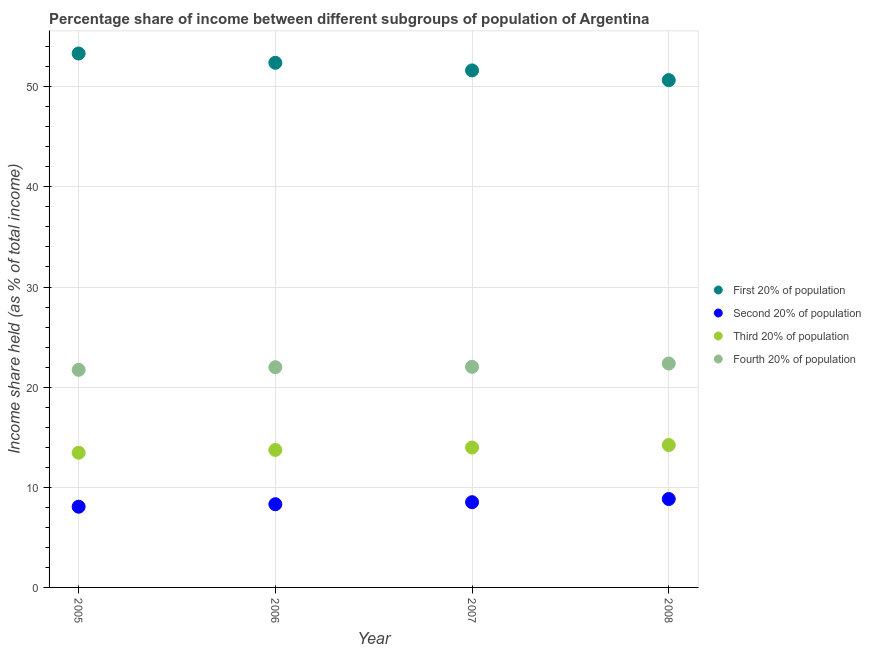How many different coloured dotlines are there?
Provide a succinct answer. 4. What is the share of the income held by third 20% of the population in 2005?
Offer a very short reply. 13.45. Across all years, what is the maximum share of the income held by second 20% of the population?
Offer a very short reply. 8.83. Across all years, what is the minimum share of the income held by third 20% of the population?
Offer a very short reply. 13.45. What is the total share of the income held by second 20% of the population in the graph?
Give a very brief answer. 33.71. What is the difference between the share of the income held by first 20% of the population in 2005 and that in 2008?
Make the answer very short. 2.66. What is the difference between the share of the income held by first 20% of the population in 2006 and the share of the income held by second 20% of the population in 2008?
Offer a very short reply. 43.56. What is the average share of the income held by fourth 20% of the population per year?
Offer a terse response. 22.03. In the year 2007, what is the difference between the share of the income held by third 20% of the population and share of the income held by first 20% of the population?
Make the answer very short. -37.66. In how many years, is the share of the income held by second 20% of the population greater than 6 %?
Offer a very short reply. 4. What is the ratio of the share of the income held by second 20% of the population in 2006 to that in 2007?
Keep it short and to the point. 0.98. What is the difference between the highest and the second highest share of the income held by first 20% of the population?
Provide a succinct answer. 0.93. What is the difference between the highest and the lowest share of the income held by third 20% of the population?
Provide a succinct answer. 0.77. Is the sum of the share of the income held by second 20% of the population in 2005 and 2008 greater than the maximum share of the income held by third 20% of the population across all years?
Keep it short and to the point. Yes. Is it the case that in every year, the sum of the share of the income held by first 20% of the population and share of the income held by fourth 20% of the population is greater than the sum of share of the income held by second 20% of the population and share of the income held by third 20% of the population?
Provide a short and direct response. Yes. Does the share of the income held by second 20% of the population monotonically increase over the years?
Offer a very short reply. Yes. What is the difference between two consecutive major ticks on the Y-axis?
Offer a very short reply. 10. Does the graph contain grids?
Provide a succinct answer. Yes. Where does the legend appear in the graph?
Give a very brief answer. Center right. How many legend labels are there?
Offer a terse response. 4. How are the legend labels stacked?
Provide a succinct answer. Vertical. What is the title of the graph?
Your answer should be compact. Percentage share of income between different subgroups of population of Argentina. What is the label or title of the X-axis?
Offer a terse response. Year. What is the label or title of the Y-axis?
Ensure brevity in your answer.  Income share held (as % of total income). What is the Income share held (as % of total income) of First 20% of population in 2005?
Your answer should be very brief. 53.32. What is the Income share held (as % of total income) in Second 20% of population in 2005?
Give a very brief answer. 8.06. What is the Income share held (as % of total income) in Third 20% of population in 2005?
Offer a terse response. 13.45. What is the Income share held (as % of total income) of Fourth 20% of population in 2005?
Your response must be concise. 21.73. What is the Income share held (as % of total income) in First 20% of population in 2006?
Make the answer very short. 52.39. What is the Income share held (as % of total income) in Second 20% of population in 2006?
Your answer should be very brief. 8.31. What is the Income share held (as % of total income) of Third 20% of population in 2006?
Ensure brevity in your answer.  13.73. What is the Income share held (as % of total income) in Fourth 20% of population in 2006?
Provide a succinct answer. 21.99. What is the Income share held (as % of total income) in First 20% of population in 2007?
Your response must be concise. 51.63. What is the Income share held (as % of total income) of Second 20% of population in 2007?
Your answer should be compact. 8.51. What is the Income share held (as % of total income) in Third 20% of population in 2007?
Your answer should be very brief. 13.97. What is the Income share held (as % of total income) in Fourth 20% of population in 2007?
Give a very brief answer. 22.03. What is the Income share held (as % of total income) of First 20% of population in 2008?
Offer a very short reply. 50.66. What is the Income share held (as % of total income) of Second 20% of population in 2008?
Your response must be concise. 8.83. What is the Income share held (as % of total income) in Third 20% of population in 2008?
Provide a succinct answer. 14.22. What is the Income share held (as % of total income) in Fourth 20% of population in 2008?
Provide a short and direct response. 22.36. Across all years, what is the maximum Income share held (as % of total income) of First 20% of population?
Make the answer very short. 53.32. Across all years, what is the maximum Income share held (as % of total income) of Second 20% of population?
Give a very brief answer. 8.83. Across all years, what is the maximum Income share held (as % of total income) in Third 20% of population?
Ensure brevity in your answer.  14.22. Across all years, what is the maximum Income share held (as % of total income) of Fourth 20% of population?
Give a very brief answer. 22.36. Across all years, what is the minimum Income share held (as % of total income) in First 20% of population?
Make the answer very short. 50.66. Across all years, what is the minimum Income share held (as % of total income) of Second 20% of population?
Give a very brief answer. 8.06. Across all years, what is the minimum Income share held (as % of total income) of Third 20% of population?
Your answer should be compact. 13.45. Across all years, what is the minimum Income share held (as % of total income) of Fourth 20% of population?
Your answer should be very brief. 21.73. What is the total Income share held (as % of total income) of First 20% of population in the graph?
Your answer should be very brief. 208. What is the total Income share held (as % of total income) in Second 20% of population in the graph?
Make the answer very short. 33.71. What is the total Income share held (as % of total income) of Third 20% of population in the graph?
Ensure brevity in your answer.  55.37. What is the total Income share held (as % of total income) in Fourth 20% of population in the graph?
Your response must be concise. 88.11. What is the difference between the Income share held (as % of total income) of First 20% of population in 2005 and that in 2006?
Provide a succinct answer. 0.93. What is the difference between the Income share held (as % of total income) in Third 20% of population in 2005 and that in 2006?
Provide a succinct answer. -0.28. What is the difference between the Income share held (as % of total income) in Fourth 20% of population in 2005 and that in 2006?
Your answer should be very brief. -0.26. What is the difference between the Income share held (as % of total income) of First 20% of population in 2005 and that in 2007?
Keep it short and to the point. 1.69. What is the difference between the Income share held (as % of total income) of Second 20% of population in 2005 and that in 2007?
Provide a succinct answer. -0.45. What is the difference between the Income share held (as % of total income) in Third 20% of population in 2005 and that in 2007?
Ensure brevity in your answer.  -0.52. What is the difference between the Income share held (as % of total income) of First 20% of population in 2005 and that in 2008?
Your answer should be compact. 2.66. What is the difference between the Income share held (as % of total income) in Second 20% of population in 2005 and that in 2008?
Offer a terse response. -0.77. What is the difference between the Income share held (as % of total income) of Third 20% of population in 2005 and that in 2008?
Your answer should be very brief. -0.77. What is the difference between the Income share held (as % of total income) in Fourth 20% of population in 2005 and that in 2008?
Your response must be concise. -0.63. What is the difference between the Income share held (as % of total income) in First 20% of population in 2006 and that in 2007?
Your response must be concise. 0.76. What is the difference between the Income share held (as % of total income) of Third 20% of population in 2006 and that in 2007?
Your response must be concise. -0.24. What is the difference between the Income share held (as % of total income) of Fourth 20% of population in 2006 and that in 2007?
Keep it short and to the point. -0.04. What is the difference between the Income share held (as % of total income) of First 20% of population in 2006 and that in 2008?
Keep it short and to the point. 1.73. What is the difference between the Income share held (as % of total income) in Second 20% of population in 2006 and that in 2008?
Provide a succinct answer. -0.52. What is the difference between the Income share held (as % of total income) of Third 20% of population in 2006 and that in 2008?
Provide a succinct answer. -0.49. What is the difference between the Income share held (as % of total income) in Fourth 20% of population in 2006 and that in 2008?
Your response must be concise. -0.37. What is the difference between the Income share held (as % of total income) of Second 20% of population in 2007 and that in 2008?
Your answer should be compact. -0.32. What is the difference between the Income share held (as % of total income) in Fourth 20% of population in 2007 and that in 2008?
Your answer should be very brief. -0.33. What is the difference between the Income share held (as % of total income) of First 20% of population in 2005 and the Income share held (as % of total income) of Second 20% of population in 2006?
Offer a terse response. 45.01. What is the difference between the Income share held (as % of total income) in First 20% of population in 2005 and the Income share held (as % of total income) in Third 20% of population in 2006?
Provide a succinct answer. 39.59. What is the difference between the Income share held (as % of total income) in First 20% of population in 2005 and the Income share held (as % of total income) in Fourth 20% of population in 2006?
Provide a short and direct response. 31.33. What is the difference between the Income share held (as % of total income) in Second 20% of population in 2005 and the Income share held (as % of total income) in Third 20% of population in 2006?
Your answer should be compact. -5.67. What is the difference between the Income share held (as % of total income) in Second 20% of population in 2005 and the Income share held (as % of total income) in Fourth 20% of population in 2006?
Offer a very short reply. -13.93. What is the difference between the Income share held (as % of total income) of Third 20% of population in 2005 and the Income share held (as % of total income) of Fourth 20% of population in 2006?
Give a very brief answer. -8.54. What is the difference between the Income share held (as % of total income) of First 20% of population in 2005 and the Income share held (as % of total income) of Second 20% of population in 2007?
Ensure brevity in your answer.  44.81. What is the difference between the Income share held (as % of total income) of First 20% of population in 2005 and the Income share held (as % of total income) of Third 20% of population in 2007?
Your answer should be compact. 39.35. What is the difference between the Income share held (as % of total income) in First 20% of population in 2005 and the Income share held (as % of total income) in Fourth 20% of population in 2007?
Make the answer very short. 31.29. What is the difference between the Income share held (as % of total income) in Second 20% of population in 2005 and the Income share held (as % of total income) in Third 20% of population in 2007?
Make the answer very short. -5.91. What is the difference between the Income share held (as % of total income) of Second 20% of population in 2005 and the Income share held (as % of total income) of Fourth 20% of population in 2007?
Keep it short and to the point. -13.97. What is the difference between the Income share held (as % of total income) in Third 20% of population in 2005 and the Income share held (as % of total income) in Fourth 20% of population in 2007?
Keep it short and to the point. -8.58. What is the difference between the Income share held (as % of total income) in First 20% of population in 2005 and the Income share held (as % of total income) in Second 20% of population in 2008?
Your answer should be compact. 44.49. What is the difference between the Income share held (as % of total income) of First 20% of population in 2005 and the Income share held (as % of total income) of Third 20% of population in 2008?
Give a very brief answer. 39.1. What is the difference between the Income share held (as % of total income) in First 20% of population in 2005 and the Income share held (as % of total income) in Fourth 20% of population in 2008?
Give a very brief answer. 30.96. What is the difference between the Income share held (as % of total income) in Second 20% of population in 2005 and the Income share held (as % of total income) in Third 20% of population in 2008?
Give a very brief answer. -6.16. What is the difference between the Income share held (as % of total income) in Second 20% of population in 2005 and the Income share held (as % of total income) in Fourth 20% of population in 2008?
Your response must be concise. -14.3. What is the difference between the Income share held (as % of total income) in Third 20% of population in 2005 and the Income share held (as % of total income) in Fourth 20% of population in 2008?
Your answer should be very brief. -8.91. What is the difference between the Income share held (as % of total income) of First 20% of population in 2006 and the Income share held (as % of total income) of Second 20% of population in 2007?
Your answer should be very brief. 43.88. What is the difference between the Income share held (as % of total income) of First 20% of population in 2006 and the Income share held (as % of total income) of Third 20% of population in 2007?
Your answer should be very brief. 38.42. What is the difference between the Income share held (as % of total income) in First 20% of population in 2006 and the Income share held (as % of total income) in Fourth 20% of population in 2007?
Give a very brief answer. 30.36. What is the difference between the Income share held (as % of total income) of Second 20% of population in 2006 and the Income share held (as % of total income) of Third 20% of population in 2007?
Provide a succinct answer. -5.66. What is the difference between the Income share held (as % of total income) in Second 20% of population in 2006 and the Income share held (as % of total income) in Fourth 20% of population in 2007?
Offer a terse response. -13.72. What is the difference between the Income share held (as % of total income) in First 20% of population in 2006 and the Income share held (as % of total income) in Second 20% of population in 2008?
Give a very brief answer. 43.56. What is the difference between the Income share held (as % of total income) in First 20% of population in 2006 and the Income share held (as % of total income) in Third 20% of population in 2008?
Give a very brief answer. 38.17. What is the difference between the Income share held (as % of total income) in First 20% of population in 2006 and the Income share held (as % of total income) in Fourth 20% of population in 2008?
Keep it short and to the point. 30.03. What is the difference between the Income share held (as % of total income) in Second 20% of population in 2006 and the Income share held (as % of total income) in Third 20% of population in 2008?
Provide a short and direct response. -5.91. What is the difference between the Income share held (as % of total income) in Second 20% of population in 2006 and the Income share held (as % of total income) in Fourth 20% of population in 2008?
Your answer should be compact. -14.05. What is the difference between the Income share held (as % of total income) in Third 20% of population in 2006 and the Income share held (as % of total income) in Fourth 20% of population in 2008?
Your response must be concise. -8.63. What is the difference between the Income share held (as % of total income) of First 20% of population in 2007 and the Income share held (as % of total income) of Second 20% of population in 2008?
Provide a succinct answer. 42.8. What is the difference between the Income share held (as % of total income) in First 20% of population in 2007 and the Income share held (as % of total income) in Third 20% of population in 2008?
Provide a short and direct response. 37.41. What is the difference between the Income share held (as % of total income) in First 20% of population in 2007 and the Income share held (as % of total income) in Fourth 20% of population in 2008?
Ensure brevity in your answer.  29.27. What is the difference between the Income share held (as % of total income) in Second 20% of population in 2007 and the Income share held (as % of total income) in Third 20% of population in 2008?
Your response must be concise. -5.71. What is the difference between the Income share held (as % of total income) of Second 20% of population in 2007 and the Income share held (as % of total income) of Fourth 20% of population in 2008?
Give a very brief answer. -13.85. What is the difference between the Income share held (as % of total income) of Third 20% of population in 2007 and the Income share held (as % of total income) of Fourth 20% of population in 2008?
Give a very brief answer. -8.39. What is the average Income share held (as % of total income) of First 20% of population per year?
Your answer should be very brief. 52. What is the average Income share held (as % of total income) of Second 20% of population per year?
Provide a succinct answer. 8.43. What is the average Income share held (as % of total income) of Third 20% of population per year?
Provide a succinct answer. 13.84. What is the average Income share held (as % of total income) in Fourth 20% of population per year?
Keep it short and to the point. 22.03. In the year 2005, what is the difference between the Income share held (as % of total income) in First 20% of population and Income share held (as % of total income) in Second 20% of population?
Ensure brevity in your answer.  45.26. In the year 2005, what is the difference between the Income share held (as % of total income) in First 20% of population and Income share held (as % of total income) in Third 20% of population?
Offer a terse response. 39.87. In the year 2005, what is the difference between the Income share held (as % of total income) of First 20% of population and Income share held (as % of total income) of Fourth 20% of population?
Ensure brevity in your answer.  31.59. In the year 2005, what is the difference between the Income share held (as % of total income) of Second 20% of population and Income share held (as % of total income) of Third 20% of population?
Your response must be concise. -5.39. In the year 2005, what is the difference between the Income share held (as % of total income) of Second 20% of population and Income share held (as % of total income) of Fourth 20% of population?
Your answer should be very brief. -13.67. In the year 2005, what is the difference between the Income share held (as % of total income) in Third 20% of population and Income share held (as % of total income) in Fourth 20% of population?
Offer a very short reply. -8.28. In the year 2006, what is the difference between the Income share held (as % of total income) of First 20% of population and Income share held (as % of total income) of Second 20% of population?
Make the answer very short. 44.08. In the year 2006, what is the difference between the Income share held (as % of total income) of First 20% of population and Income share held (as % of total income) of Third 20% of population?
Your answer should be compact. 38.66. In the year 2006, what is the difference between the Income share held (as % of total income) in First 20% of population and Income share held (as % of total income) in Fourth 20% of population?
Make the answer very short. 30.4. In the year 2006, what is the difference between the Income share held (as % of total income) in Second 20% of population and Income share held (as % of total income) in Third 20% of population?
Ensure brevity in your answer.  -5.42. In the year 2006, what is the difference between the Income share held (as % of total income) in Second 20% of population and Income share held (as % of total income) in Fourth 20% of population?
Your answer should be very brief. -13.68. In the year 2006, what is the difference between the Income share held (as % of total income) of Third 20% of population and Income share held (as % of total income) of Fourth 20% of population?
Offer a very short reply. -8.26. In the year 2007, what is the difference between the Income share held (as % of total income) in First 20% of population and Income share held (as % of total income) in Second 20% of population?
Ensure brevity in your answer.  43.12. In the year 2007, what is the difference between the Income share held (as % of total income) of First 20% of population and Income share held (as % of total income) of Third 20% of population?
Your response must be concise. 37.66. In the year 2007, what is the difference between the Income share held (as % of total income) in First 20% of population and Income share held (as % of total income) in Fourth 20% of population?
Your response must be concise. 29.6. In the year 2007, what is the difference between the Income share held (as % of total income) of Second 20% of population and Income share held (as % of total income) of Third 20% of population?
Provide a short and direct response. -5.46. In the year 2007, what is the difference between the Income share held (as % of total income) of Second 20% of population and Income share held (as % of total income) of Fourth 20% of population?
Your response must be concise. -13.52. In the year 2007, what is the difference between the Income share held (as % of total income) in Third 20% of population and Income share held (as % of total income) in Fourth 20% of population?
Make the answer very short. -8.06. In the year 2008, what is the difference between the Income share held (as % of total income) in First 20% of population and Income share held (as % of total income) in Second 20% of population?
Offer a terse response. 41.83. In the year 2008, what is the difference between the Income share held (as % of total income) in First 20% of population and Income share held (as % of total income) in Third 20% of population?
Make the answer very short. 36.44. In the year 2008, what is the difference between the Income share held (as % of total income) in First 20% of population and Income share held (as % of total income) in Fourth 20% of population?
Give a very brief answer. 28.3. In the year 2008, what is the difference between the Income share held (as % of total income) of Second 20% of population and Income share held (as % of total income) of Third 20% of population?
Keep it short and to the point. -5.39. In the year 2008, what is the difference between the Income share held (as % of total income) in Second 20% of population and Income share held (as % of total income) in Fourth 20% of population?
Your answer should be very brief. -13.53. In the year 2008, what is the difference between the Income share held (as % of total income) of Third 20% of population and Income share held (as % of total income) of Fourth 20% of population?
Provide a short and direct response. -8.14. What is the ratio of the Income share held (as % of total income) in First 20% of population in 2005 to that in 2006?
Provide a succinct answer. 1.02. What is the ratio of the Income share held (as % of total income) of Second 20% of population in 2005 to that in 2006?
Provide a short and direct response. 0.97. What is the ratio of the Income share held (as % of total income) in Third 20% of population in 2005 to that in 2006?
Make the answer very short. 0.98. What is the ratio of the Income share held (as % of total income) in Fourth 20% of population in 2005 to that in 2006?
Offer a very short reply. 0.99. What is the ratio of the Income share held (as % of total income) in First 20% of population in 2005 to that in 2007?
Offer a very short reply. 1.03. What is the ratio of the Income share held (as % of total income) of Second 20% of population in 2005 to that in 2007?
Your answer should be compact. 0.95. What is the ratio of the Income share held (as % of total income) of Third 20% of population in 2005 to that in 2007?
Provide a short and direct response. 0.96. What is the ratio of the Income share held (as % of total income) of Fourth 20% of population in 2005 to that in 2007?
Give a very brief answer. 0.99. What is the ratio of the Income share held (as % of total income) of First 20% of population in 2005 to that in 2008?
Your answer should be very brief. 1.05. What is the ratio of the Income share held (as % of total income) in Second 20% of population in 2005 to that in 2008?
Your answer should be very brief. 0.91. What is the ratio of the Income share held (as % of total income) in Third 20% of population in 2005 to that in 2008?
Ensure brevity in your answer.  0.95. What is the ratio of the Income share held (as % of total income) in Fourth 20% of population in 2005 to that in 2008?
Ensure brevity in your answer.  0.97. What is the ratio of the Income share held (as % of total income) of First 20% of population in 2006 to that in 2007?
Offer a very short reply. 1.01. What is the ratio of the Income share held (as % of total income) of Second 20% of population in 2006 to that in 2007?
Ensure brevity in your answer.  0.98. What is the ratio of the Income share held (as % of total income) of Third 20% of population in 2006 to that in 2007?
Provide a succinct answer. 0.98. What is the ratio of the Income share held (as % of total income) in Fourth 20% of population in 2006 to that in 2007?
Ensure brevity in your answer.  1. What is the ratio of the Income share held (as % of total income) in First 20% of population in 2006 to that in 2008?
Offer a terse response. 1.03. What is the ratio of the Income share held (as % of total income) of Second 20% of population in 2006 to that in 2008?
Your answer should be compact. 0.94. What is the ratio of the Income share held (as % of total income) in Third 20% of population in 2006 to that in 2008?
Make the answer very short. 0.97. What is the ratio of the Income share held (as % of total income) in Fourth 20% of population in 2006 to that in 2008?
Your answer should be compact. 0.98. What is the ratio of the Income share held (as % of total income) of First 20% of population in 2007 to that in 2008?
Your answer should be compact. 1.02. What is the ratio of the Income share held (as % of total income) in Second 20% of population in 2007 to that in 2008?
Your answer should be very brief. 0.96. What is the ratio of the Income share held (as % of total income) in Third 20% of population in 2007 to that in 2008?
Your answer should be compact. 0.98. What is the ratio of the Income share held (as % of total income) in Fourth 20% of population in 2007 to that in 2008?
Ensure brevity in your answer.  0.99. What is the difference between the highest and the second highest Income share held (as % of total income) of Second 20% of population?
Your answer should be very brief. 0.32. What is the difference between the highest and the second highest Income share held (as % of total income) of Fourth 20% of population?
Your response must be concise. 0.33. What is the difference between the highest and the lowest Income share held (as % of total income) in First 20% of population?
Your response must be concise. 2.66. What is the difference between the highest and the lowest Income share held (as % of total income) of Second 20% of population?
Offer a terse response. 0.77. What is the difference between the highest and the lowest Income share held (as % of total income) of Third 20% of population?
Your response must be concise. 0.77. What is the difference between the highest and the lowest Income share held (as % of total income) in Fourth 20% of population?
Keep it short and to the point. 0.63. 